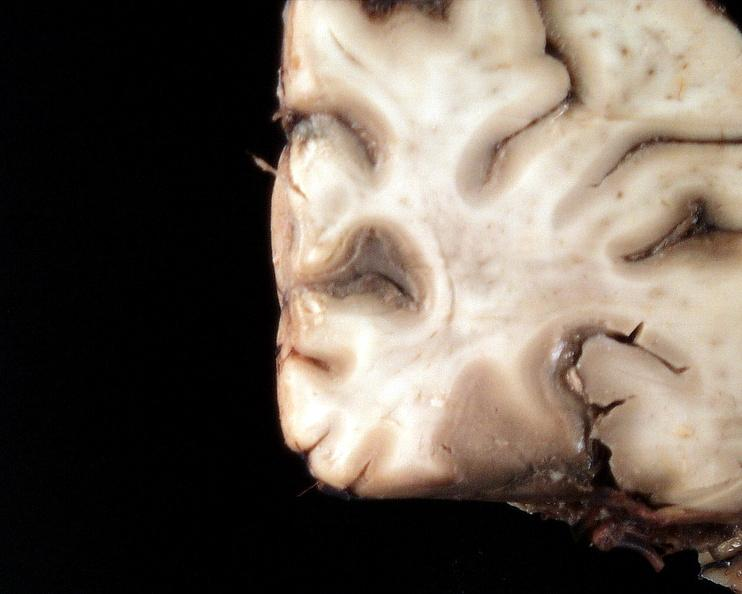s nervous present?
Answer the question using a single word or phrase. Yes 